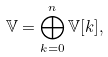Convert formula to latex. <formula><loc_0><loc_0><loc_500><loc_500>\mathbb { V } = \bigoplus _ { k = 0 } ^ { n } \mathbb { V } [ k ] ,</formula> 